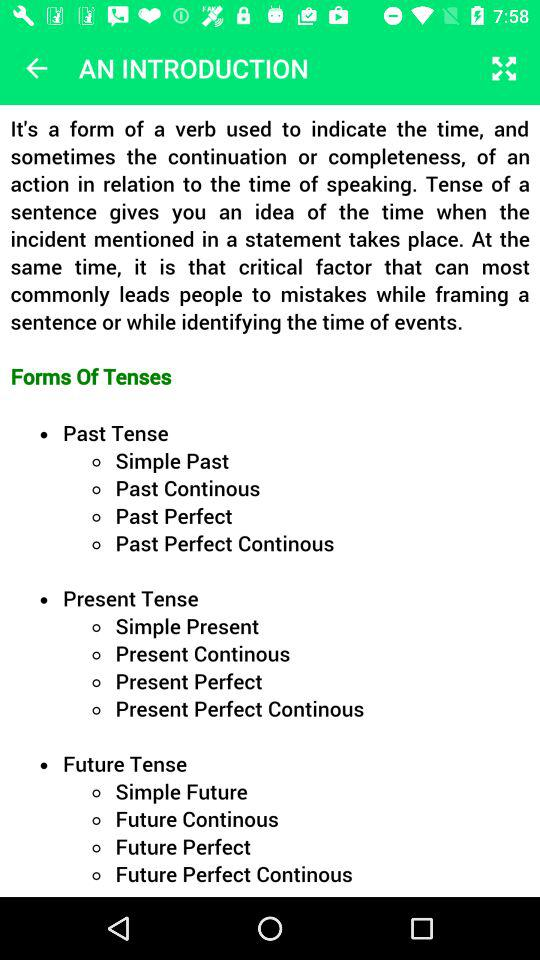How many present tenses are there?
Answer the question using a single word or phrase. 4 